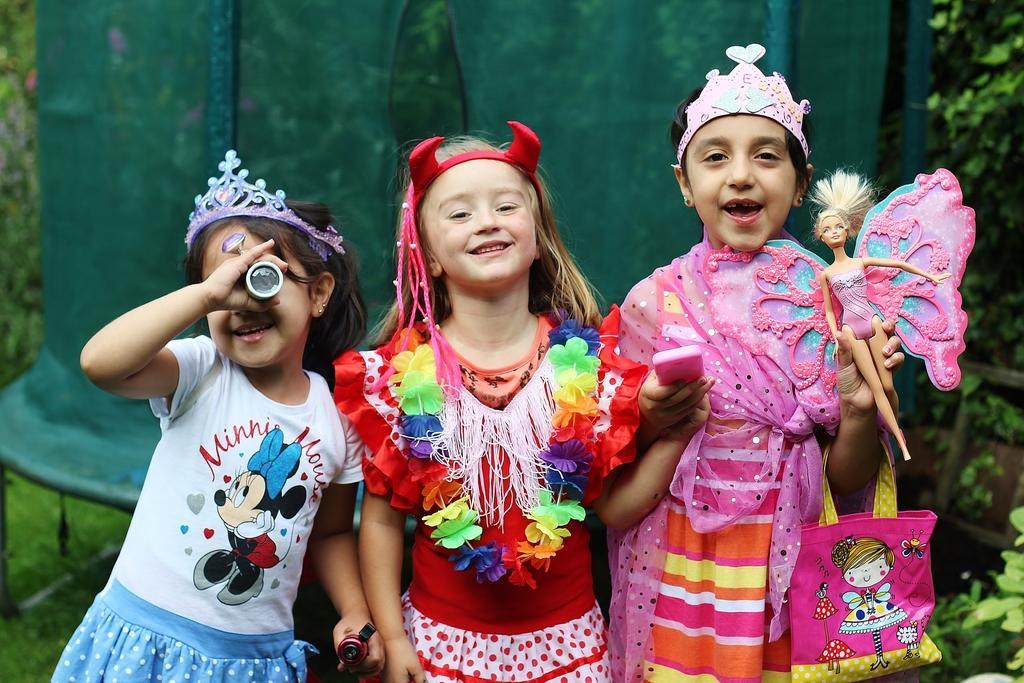Can you describe this image briefly? This picture seems to be of outside. On the right there is a girl wearing pink color Crown, holding a Barbie girl, wearing a bag and standing. In the center there is a girl smiling and standing. On the left we can see a girl wearing a white color frock smiling and standing. In the background there is a net and some plants. 